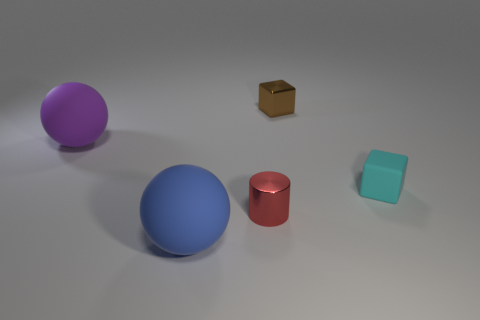Add 4 tiny brown shiny cubes. How many objects exist? 9 Subtract all spheres. How many objects are left? 3 Add 1 brown blocks. How many brown blocks are left? 2 Add 5 cylinders. How many cylinders exist? 6 Subtract 0 gray spheres. How many objects are left? 5 Subtract all tiny brown metal things. Subtract all small cyan matte things. How many objects are left? 3 